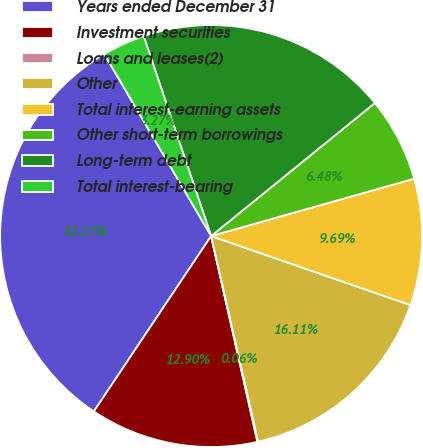Convert chart to OTSL. <chart><loc_0><loc_0><loc_500><loc_500><pie_chart><fcel>Years ended December 31<fcel>Investment securities<fcel>Loans and leases(2)<fcel>Other<fcel>Total interest-earning assets<fcel>Other short-term borrowings<fcel>Long-term debt<fcel>Total interest-bearing<nl><fcel>32.17%<fcel>12.9%<fcel>0.06%<fcel>16.11%<fcel>9.69%<fcel>6.48%<fcel>19.32%<fcel>3.27%<nl></chart> 